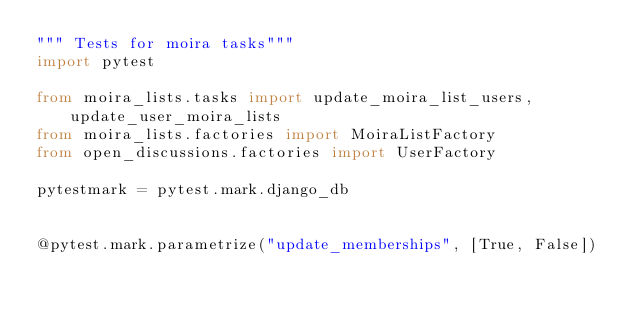<code> <loc_0><loc_0><loc_500><loc_500><_Python_>""" Tests for moira tasks"""
import pytest

from moira_lists.tasks import update_moira_list_users, update_user_moira_lists
from moira_lists.factories import MoiraListFactory
from open_discussions.factories import UserFactory

pytestmark = pytest.mark.django_db


@pytest.mark.parametrize("update_memberships", [True, False])</code> 